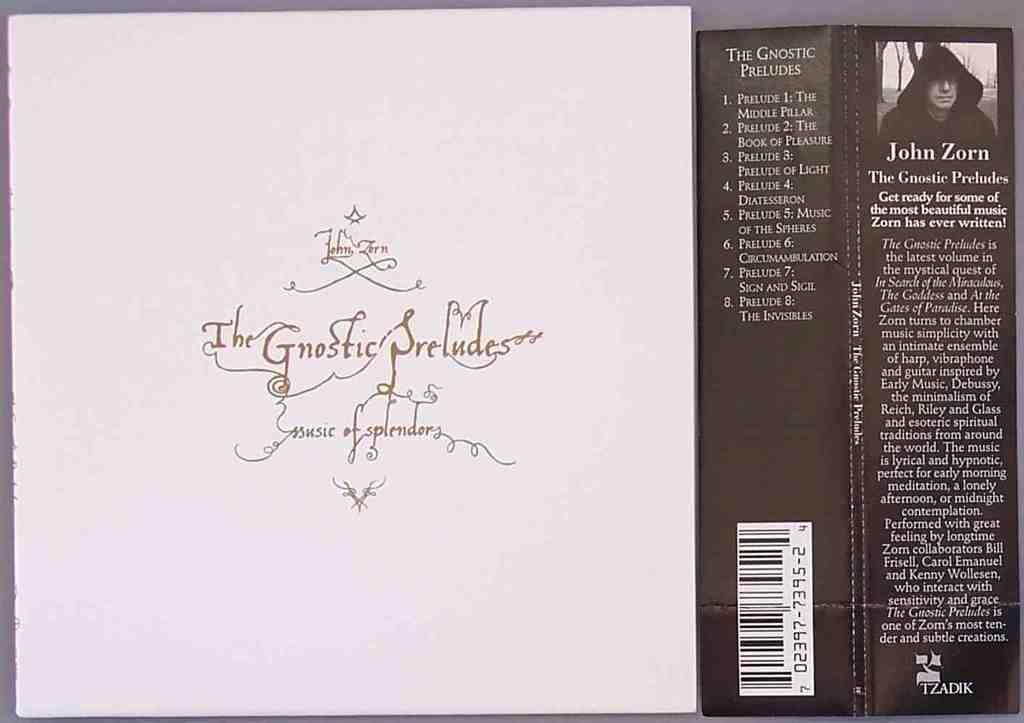Please provide a concise description of this image. In this picture we can see boards with a person and some text on it. 